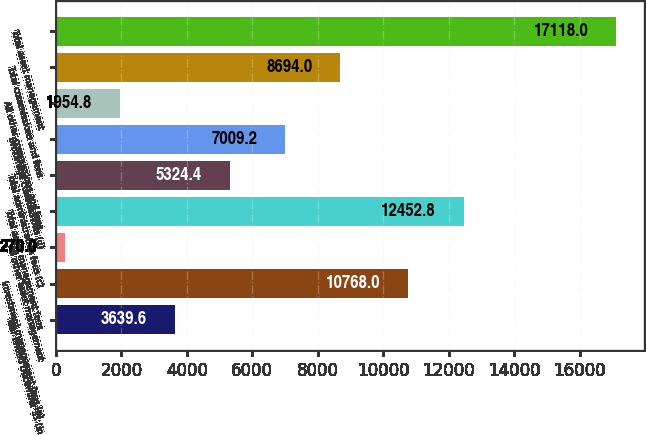<chart> <loc_0><loc_0><loc_500><loc_500><bar_chart><fcel>Year ended December 31 (in<fcel>Investment management fees (a)<fcel>All other asset management<fcel>Total asset management fees<fcel>Total administration fees (c)<fcel>Brokerage commissions (d)<fcel>All other commissions and fees<fcel>Total commissions and fees<fcel>Total asset management<nl><fcel>3639.6<fcel>10768<fcel>270<fcel>12452.8<fcel>5324.4<fcel>7009.2<fcel>1954.8<fcel>8694<fcel>17118<nl></chart> 